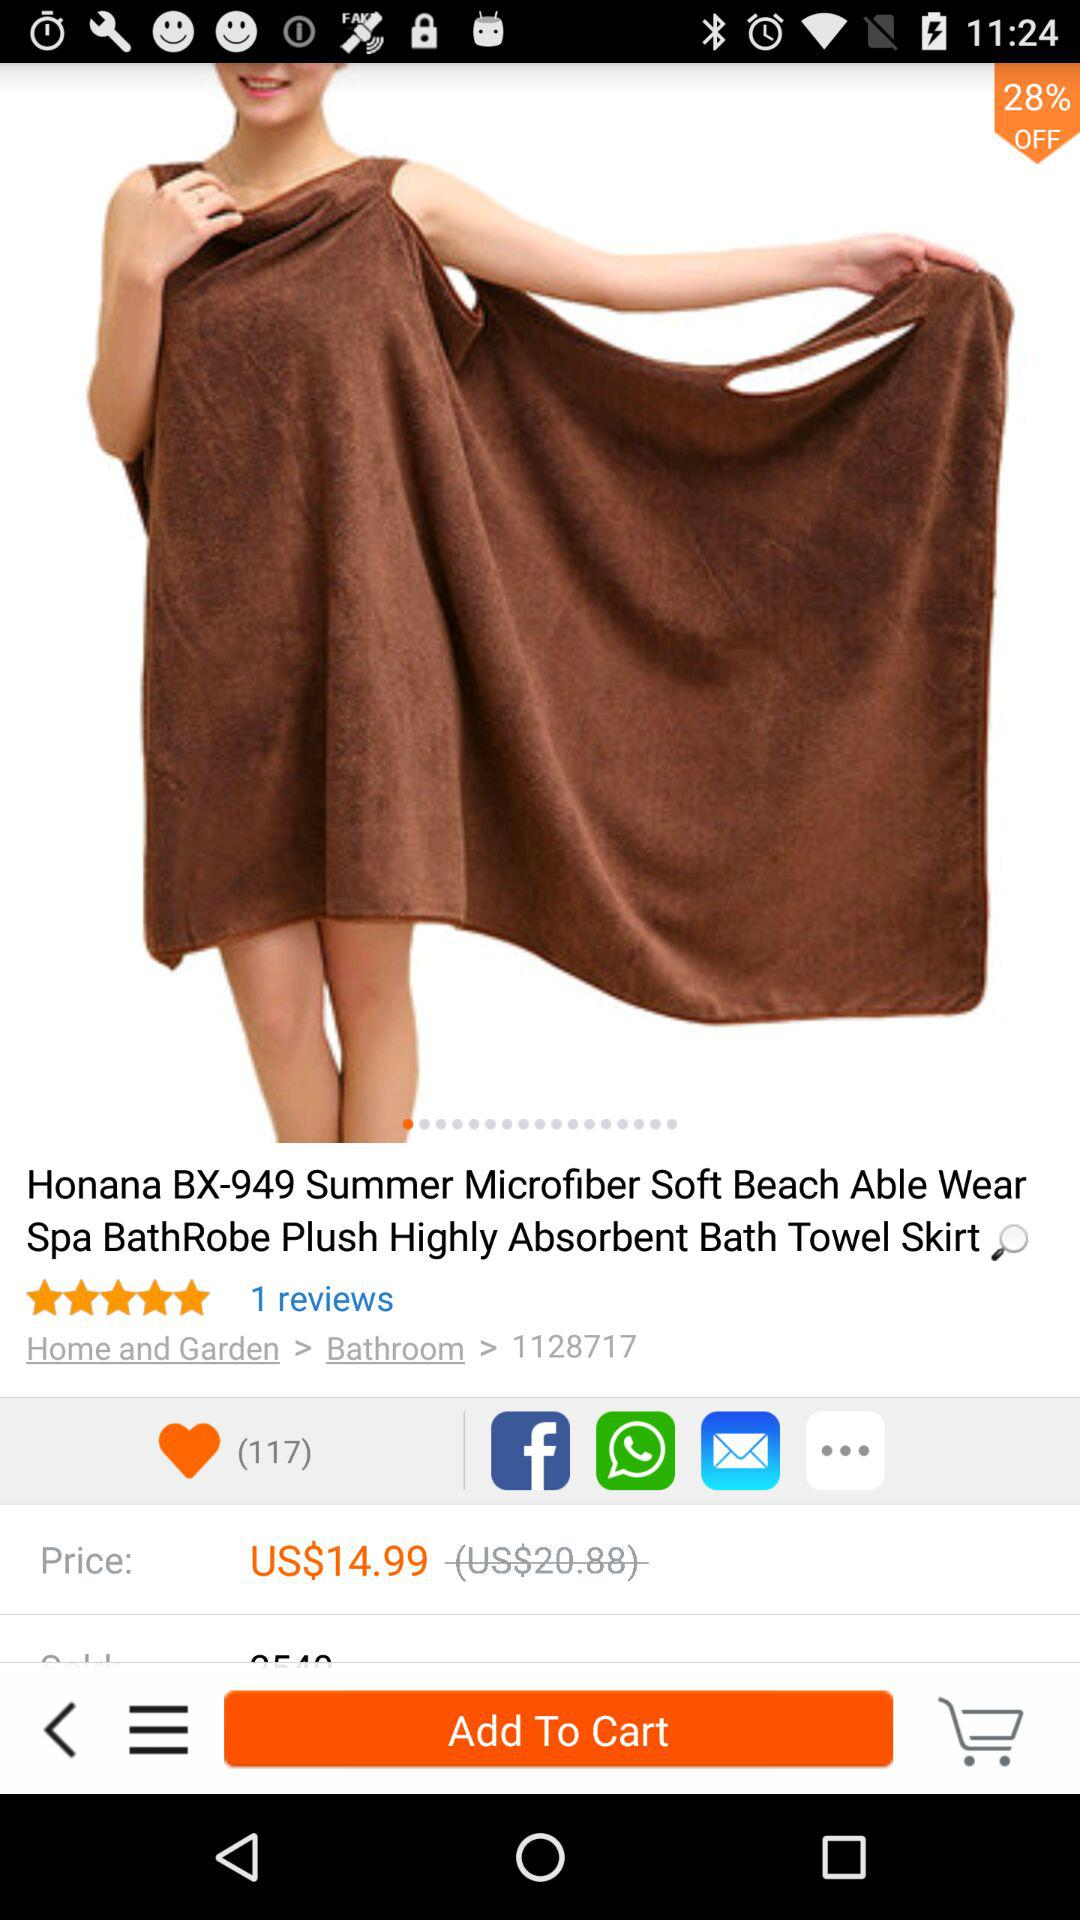Which application is used for share?
When the provided information is insufficient, respond with <no answer>. <no answer> 